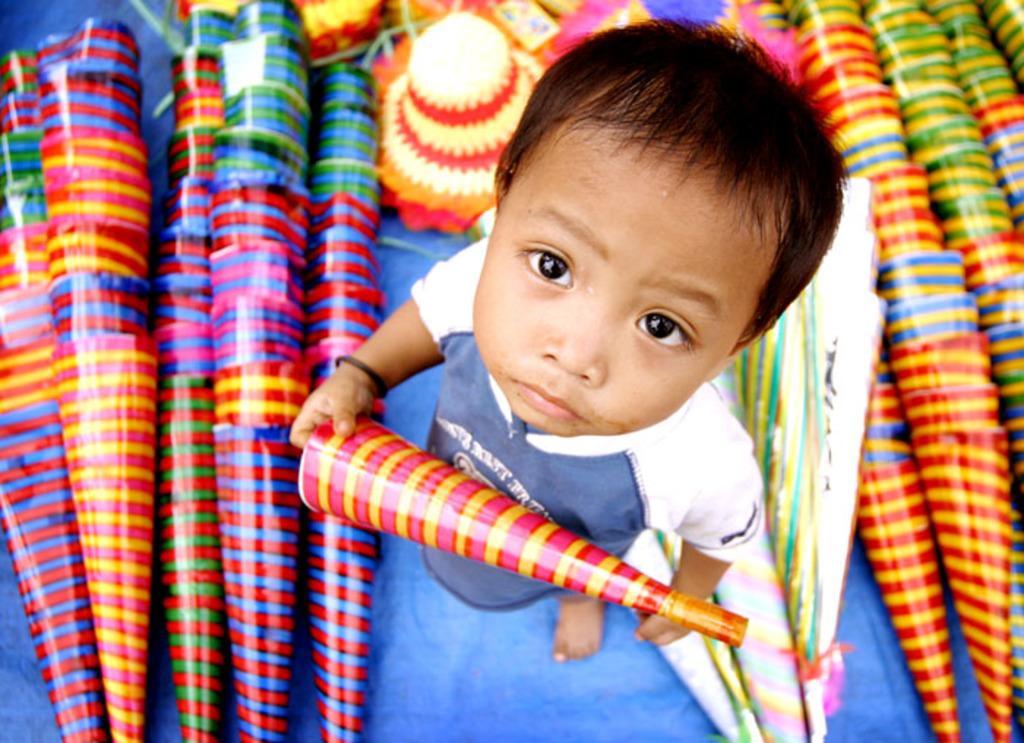How would you summarize this image in a sentence or two? In this image we can see a kid is holding an object. In the background we can see objects. 